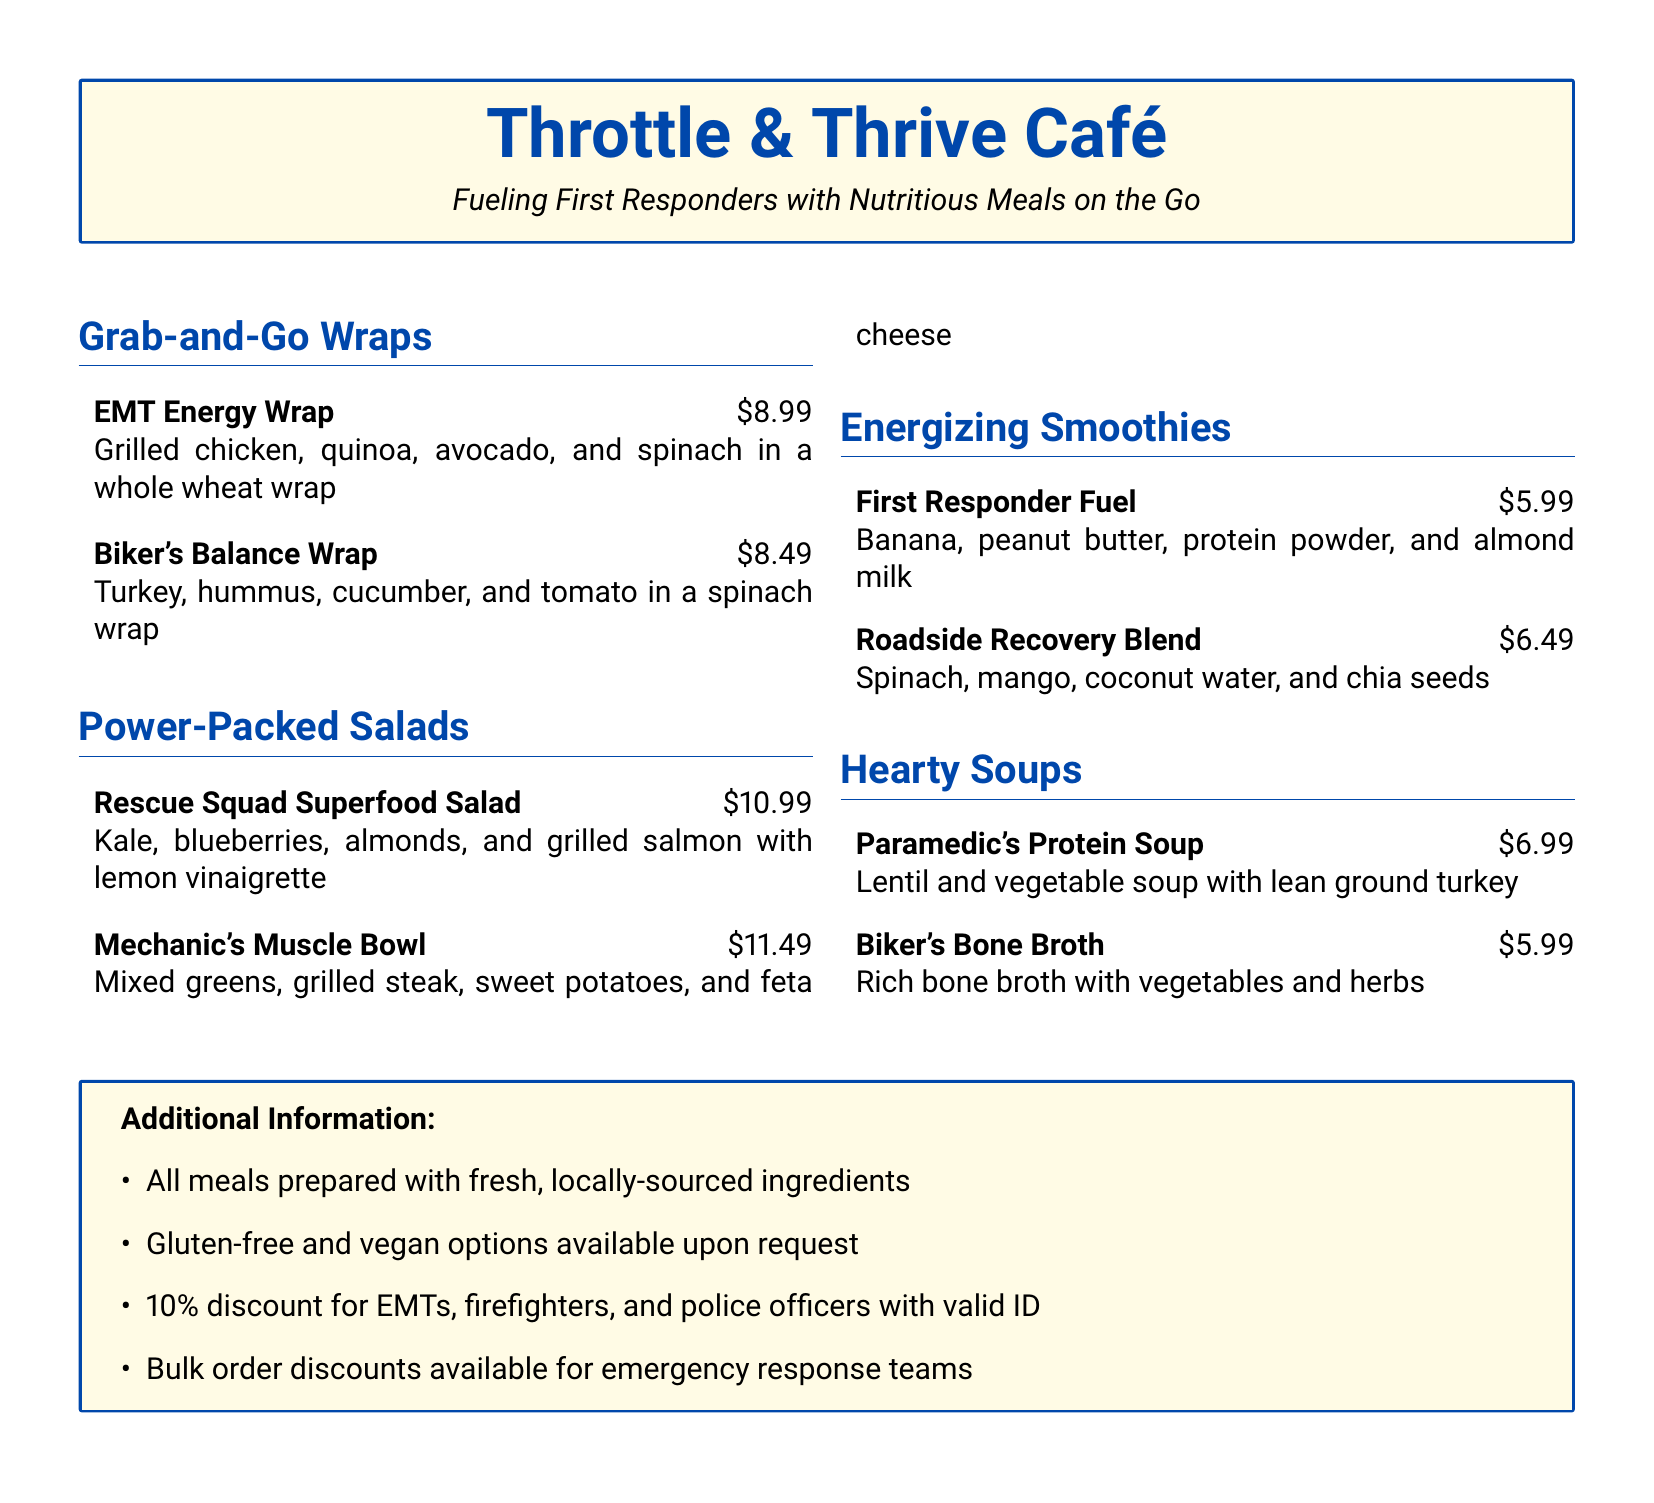What is the price of the EMT Energy Wrap? The EMT Energy Wrap is priced at $8.99 as listed in the menu.
Answer: $8.99 What ingredients are in the Rescue Squad Superfood Salad? The Rescue Squad Superfood Salad contains kale, blueberries, almonds, and grilled salmon with lemon vinaigrette.
Answer: Kale, blueberries, almonds, and grilled salmon How much does the First Responder Fuel smoothie cost? The cost of the First Responder Fuel smoothie is mentioned in the menu as $5.99.
Answer: $5.99 What is the discount percentage for EMTs with valid ID? The menu states a 10% discount for EMTs, firefighters, and police officers with valid ID.
Answer: 10% List one gluten-free option noted in the café. The menu indicates that gluten-free options are available upon request; however, a specific dish is not named.
Answer: Available upon request How many types of soups are offered on the menu? There are two types of soups listed in the menu: the Paramedic's Protein Soup and Biker's Bone Broth.
Answer: Two What is the primary focus of the Throttle & Thrive Café? The café aims to fuel first responders with nutritious meals on the go, as indicated in the subtitle.
Answer: Nutritious meals on the go What type of wrap is the Biker’s Balance Wrap made with? The Biker's Balance Wrap is made in a spinach wrap according to the menu description.
Answer: Spinach wrap 